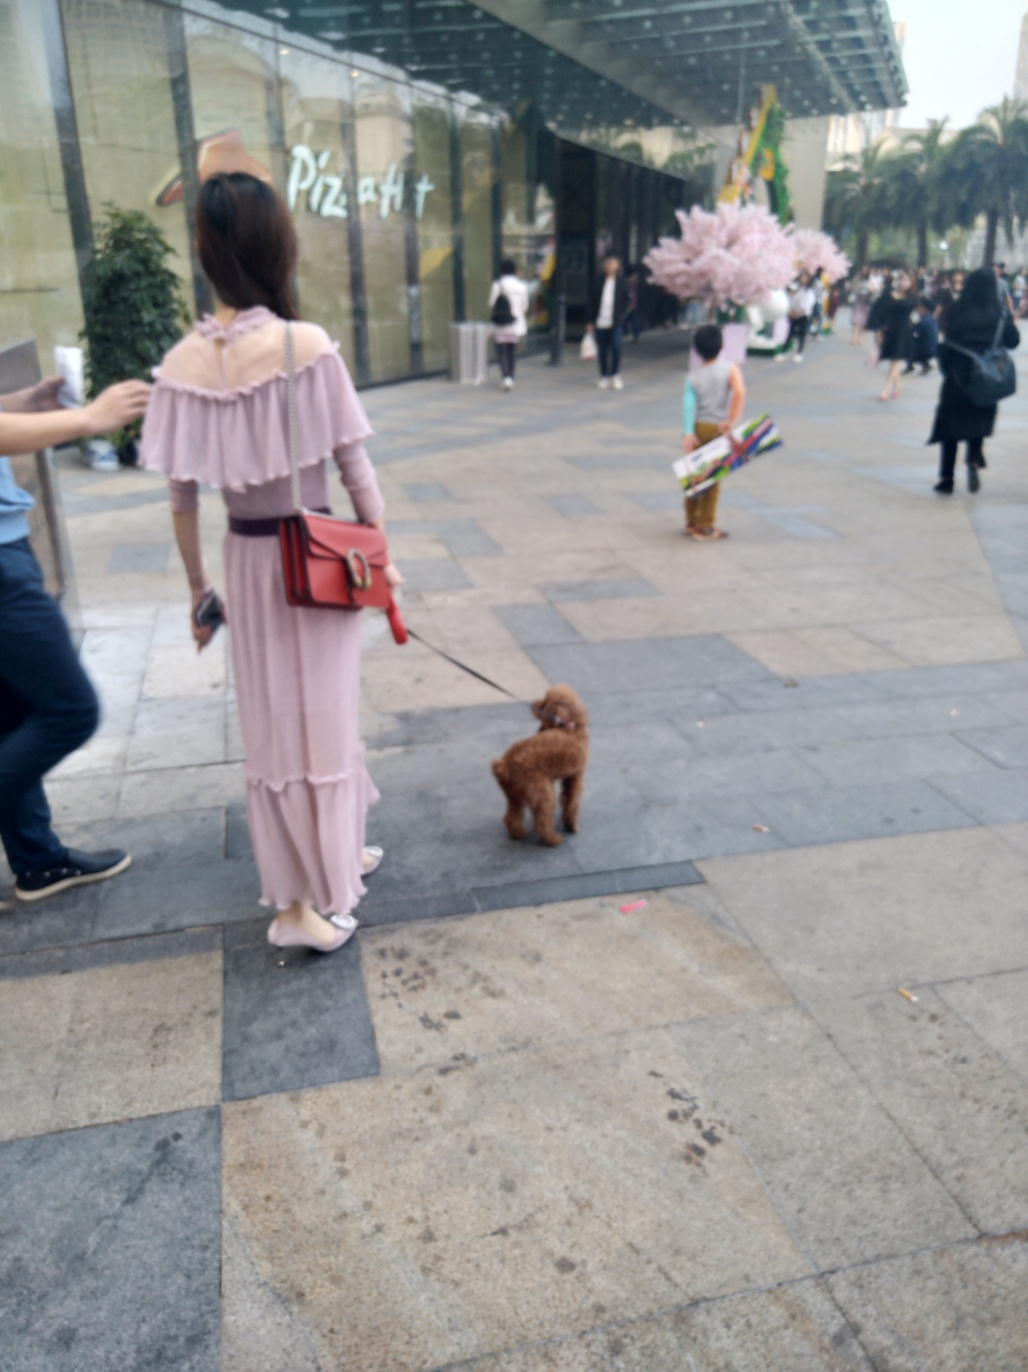What are the main subjects in this image?
A. Pedestrians, road, shopping mall
B. Animals, mountains, rivers
C. Buildings, trees, sky
D. Cars, bicycles, traffic lights
Answer with the option's letter from the given choices directly.
 A. 